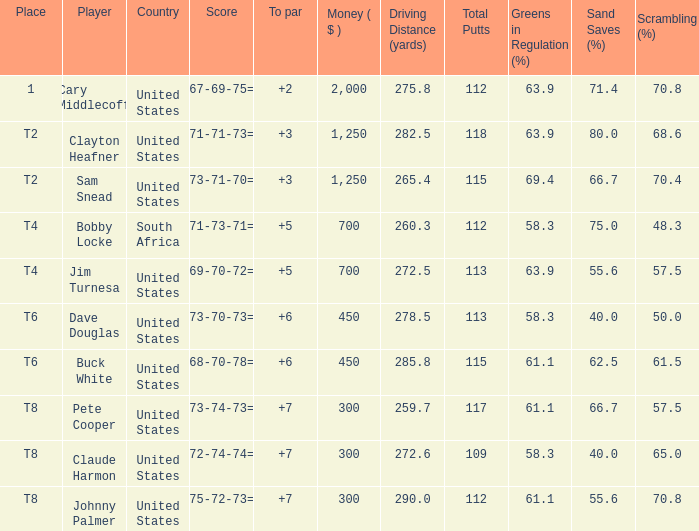What is the Johnny Palmer with a To larger than 6 Money sum? 300.0. 